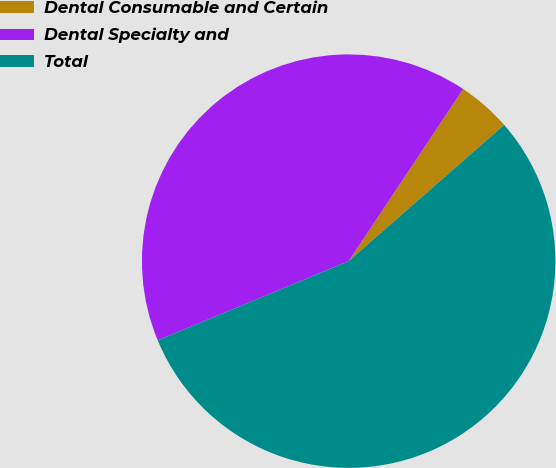<chart> <loc_0><loc_0><loc_500><loc_500><pie_chart><fcel>Dental Consumable and Certain<fcel>Dental Specialty and<fcel>Total<nl><fcel>4.21%<fcel>40.6%<fcel>55.19%<nl></chart> 